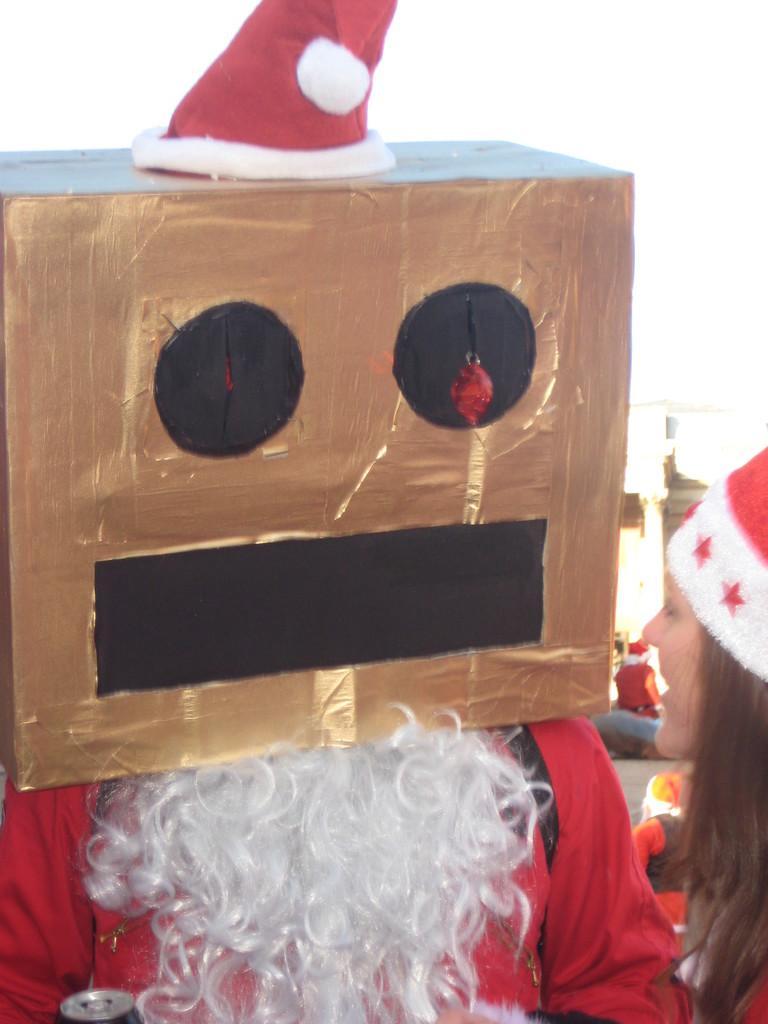Can you describe this image briefly? In this picture there is a person covering his face with the carton box. He is wearing Santa Claus dress. Towards the right there is a woman wearing a cap. 